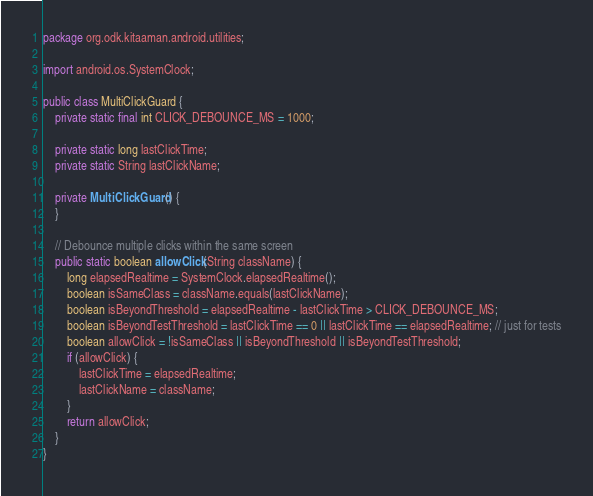<code> <loc_0><loc_0><loc_500><loc_500><_Java_>package org.odk.kitaaman.android.utilities;

import android.os.SystemClock;

public class MultiClickGuard {
    private static final int CLICK_DEBOUNCE_MS = 1000;

    private static long lastClickTime;
    private static String lastClickName;

    private MultiClickGuard() {
    }

    // Debounce multiple clicks within the same screen
    public static boolean allowClick(String className) {
        long elapsedRealtime = SystemClock.elapsedRealtime();
        boolean isSameClass = className.equals(lastClickName);
        boolean isBeyondThreshold = elapsedRealtime - lastClickTime > CLICK_DEBOUNCE_MS;
        boolean isBeyondTestThreshold = lastClickTime == 0 || lastClickTime == elapsedRealtime; // just for tests
        boolean allowClick = !isSameClass || isBeyondThreshold || isBeyondTestThreshold;
        if (allowClick) {
            lastClickTime = elapsedRealtime;
            lastClickName = className;
        }
        return allowClick;
    }
}
</code> 